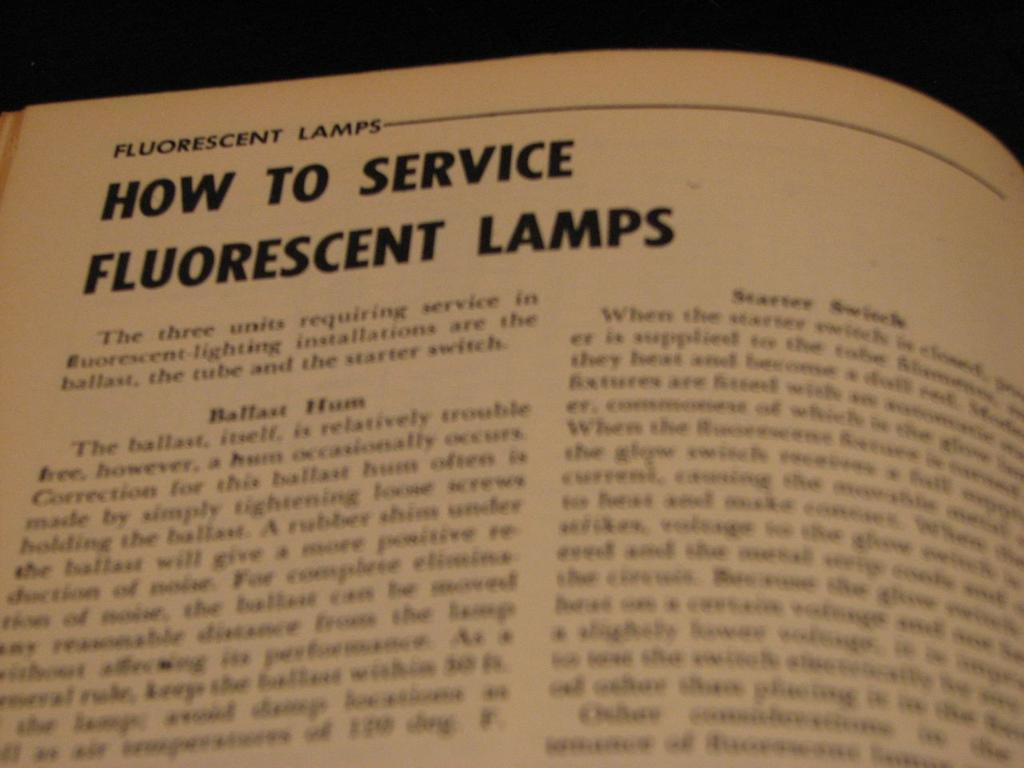<image>
Describe the image concisely. A book is opened to a page describing how to service fluorescent lamps. 